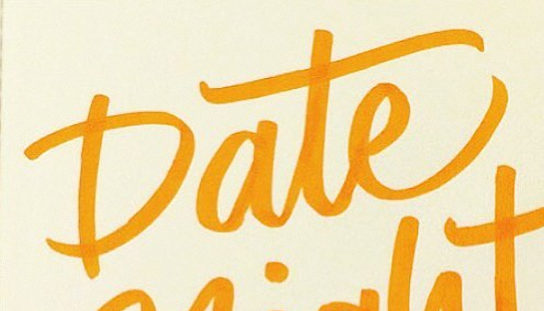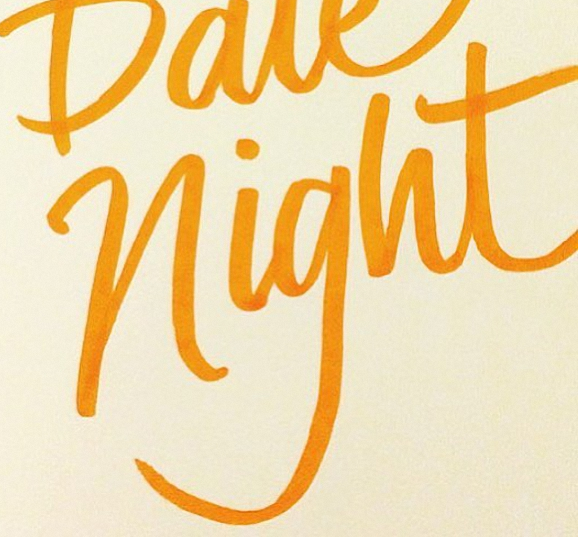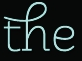What text is displayed in these images sequentially, separated by a semicolon? Date; night; the 